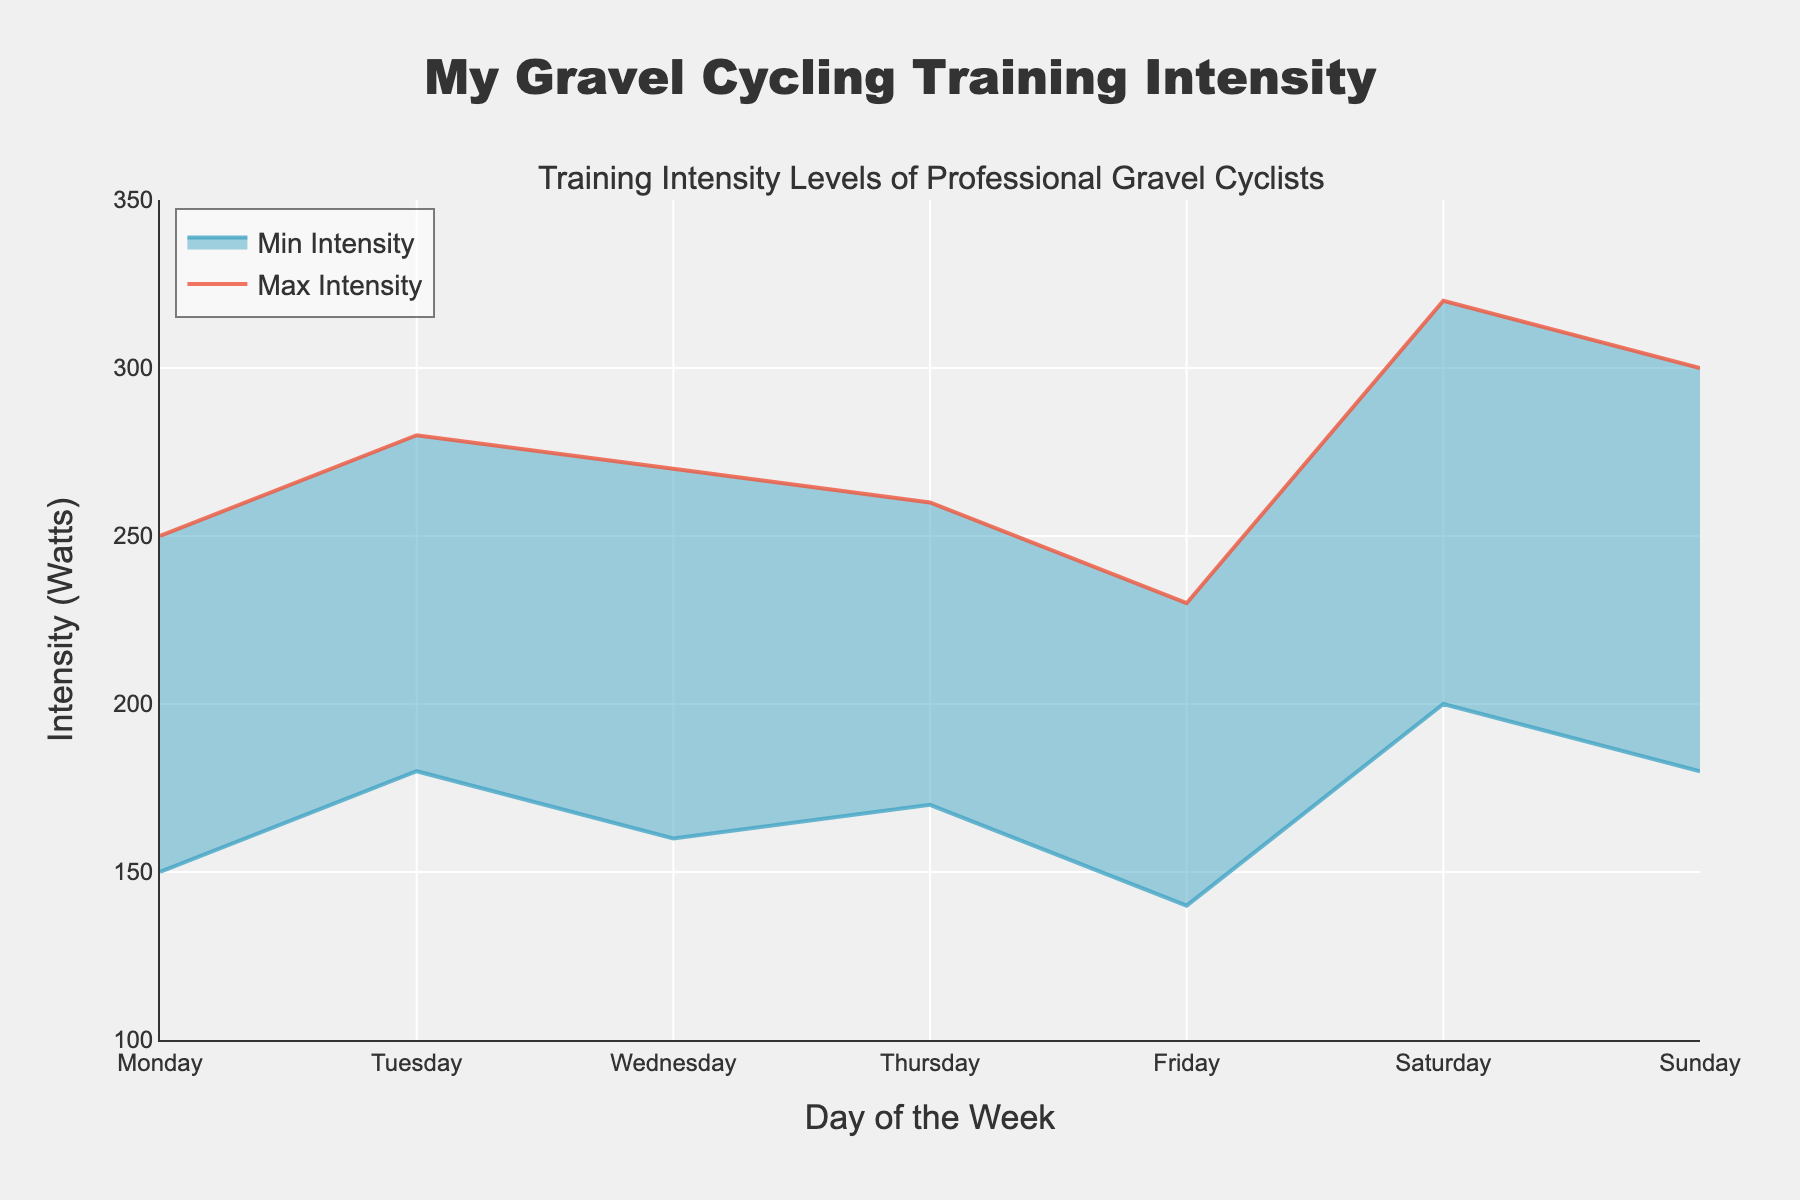What is the title of the chart? The title of the chart is displayed at the top-center part of the figure. It reads "My Gravel Cycling Training Intensity."
Answer: My Gravel Cycling Training Intensity What does the x-axis represent? The x-axis represents the days of the week, shown as Monday, Tuesday, Wednesday, Thursday, Friday, Saturday, and Sunday.
Answer: Days of the Week What does the y-axis represent? The y-axis represents the intensity in watts, which is the measure of training intensity levels.
Answer: Intensity (Watts) On which day is the maximum intensity highest? The highest peak on the upper boundary (Max Intensity - Watts) of the range area chart is on Saturday.
Answer: Saturday What is the range of intensity levels on Friday? The range is the difference between the maximum (230 Watts) and minimum (140 Watts) intensity on Friday. Subtracting these values gives 230 - 140 = 90 Watts.
Answer: 90 Watts Which day shows the smallest variation in intensity levels? To find the smallest variation, look for the smallest difference between the max and min intensity levels for each day. Wednesday has a range from 160 to 270 Watts, giving a variation of 110 Watts, which is the smallest difference among all days.
Answer: Wednesday What is the average maximum intensity level across the week? The max intensities for the week are 250, 280, 270, 260, 230, 320, and 300 Watts. Summing these values gives 1910. To find the average, divide 1910 by 7, which is approximately 273 Watts.
Answer: 273 Watts Which day has a higher minimum intensity: Thursday or Tuesday? Tuesday's minimum intensity is 180 Watts, and Thursday's is 170 Watts. A direct comparison shows that Tuesday has the higher minimum intensity.
Answer: Tuesday How much greater is the maximum intensity on Sunday compared to Monday? Sunday's maximum intensity is 300 Watts, and Monday's is 250 Watts. The difference is 300 - 250 = 50 Watts.
Answer: 50 Watts If you need to avoid high-intensity training, which days should you focus on based on minimum intensity levels? The days with the lowest minimum intensities are Friday (140 Watts) and Monday (150 Watts). These days have the lowest base-level training intensities.
Answer: Friday and Monday 